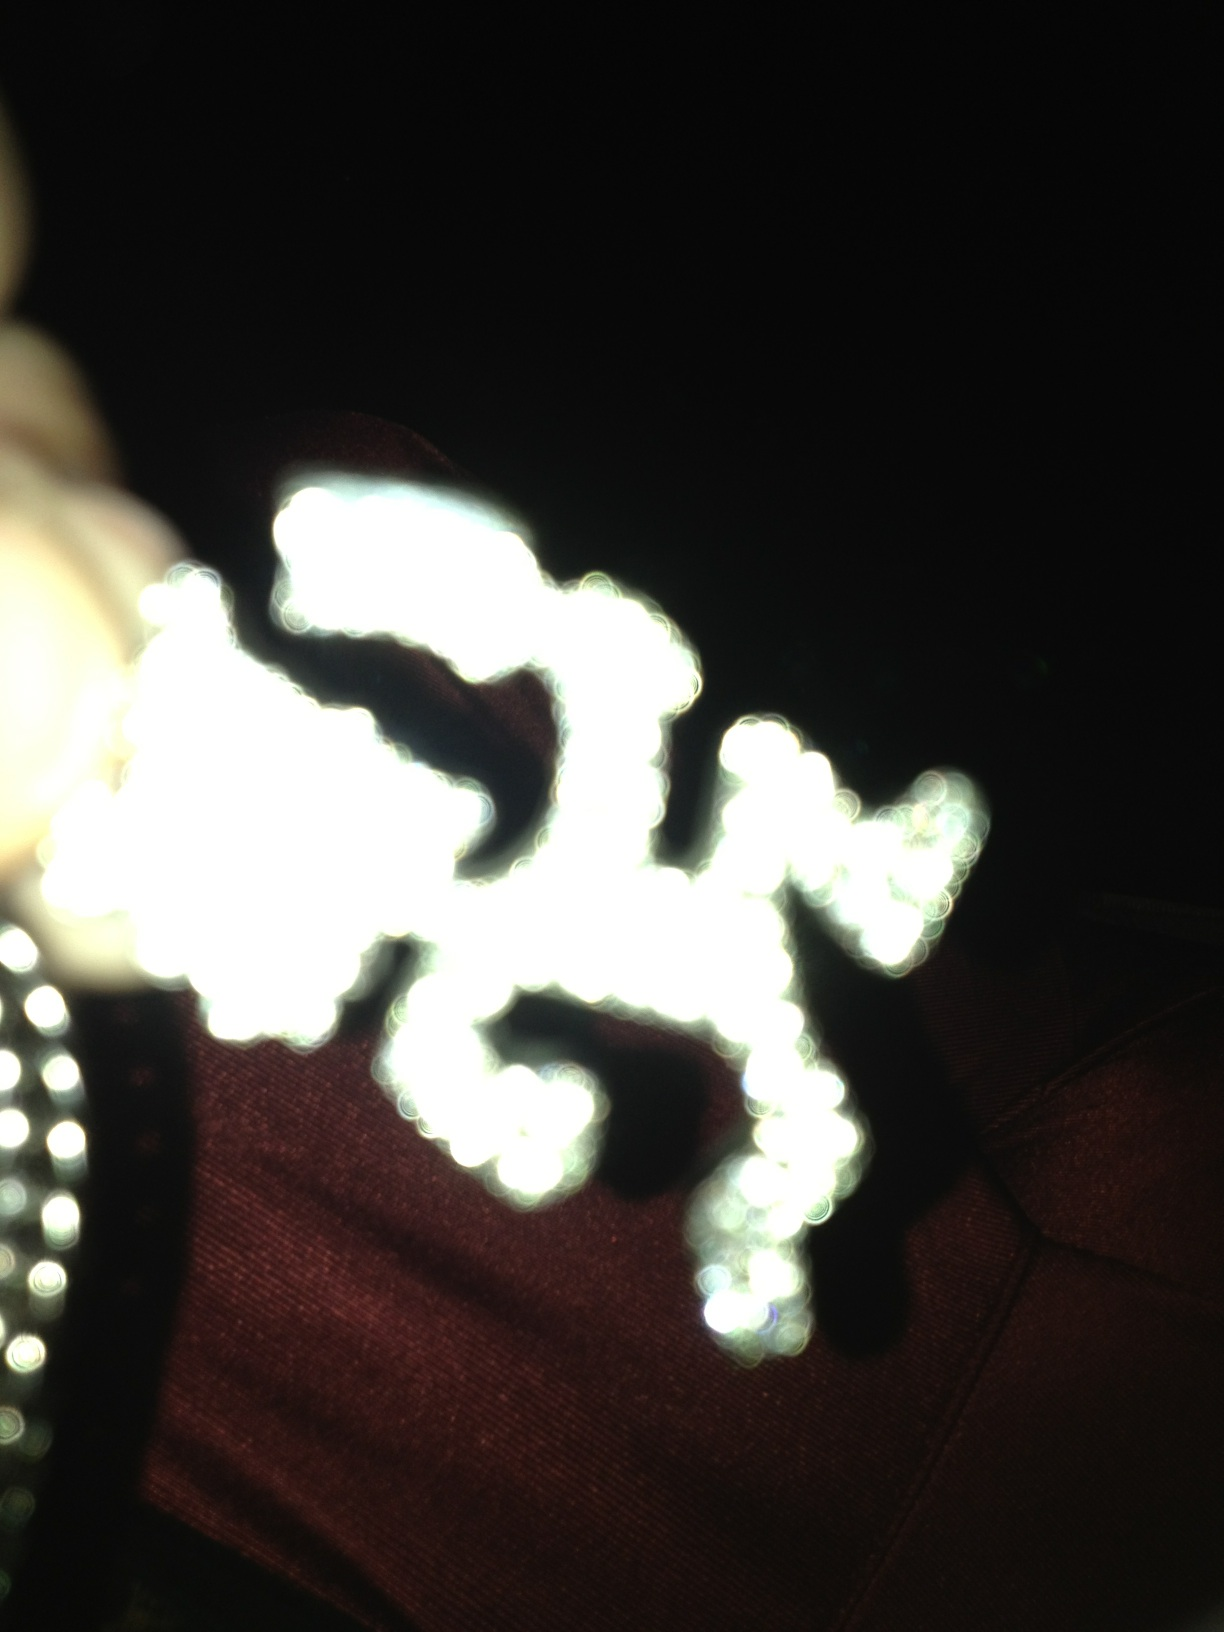Can you tell what object this is? The image is too blurred to clearly identify the object. It appears to be somewhat intricate and might be a piece of jewelry or decorative item based on the shiny reflections. For a precise identification, a clearer or more focused image would be necessary. 